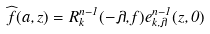<formula> <loc_0><loc_0><loc_500><loc_500>\widehat { f } ( a , z ) = R _ { k } ^ { n - 1 } ( - \lambda , f ) e _ { k , \lambda } ^ { n - 1 } ( z , 0 )</formula> 